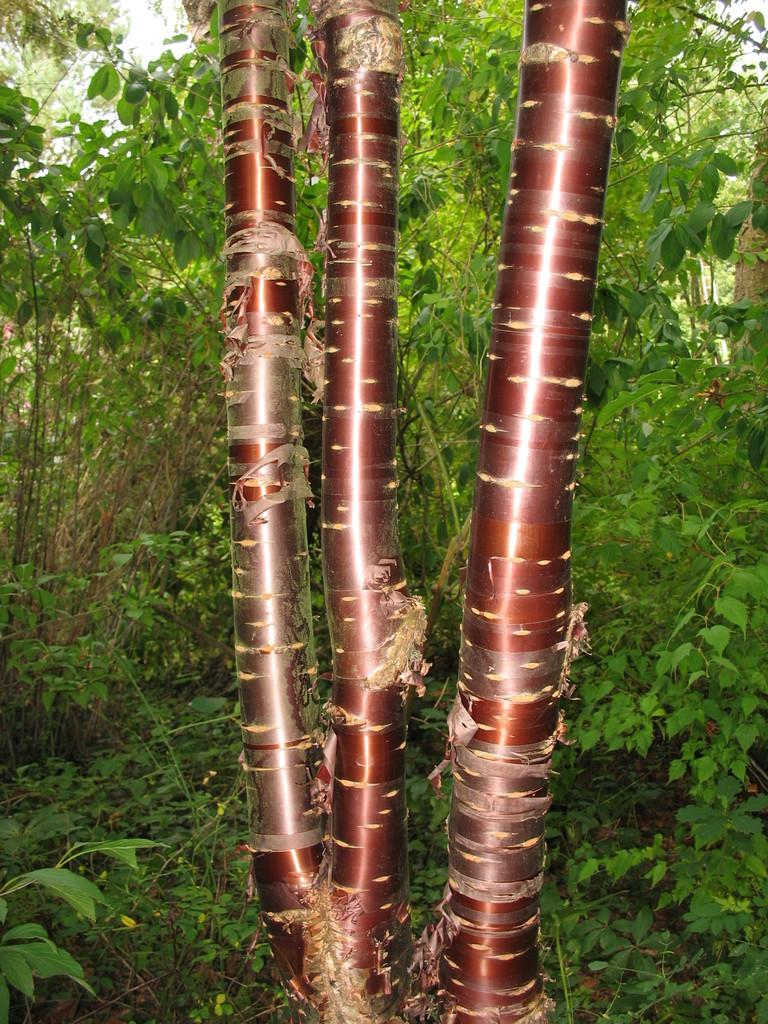What is located in the front of the image? There is a branch of a tree in the front of the image. What can be seen in the background of the image? There are trees in the background of the image. What type of vegetation is on the ground in the image? There is grass on the ground in the image. What type of amusement can be seen in the image? There is no amusement present in the image; it features a branch of a tree, trees in the background, and grass on the ground. How many babies are visible in the image? There are no babies present in the image. 